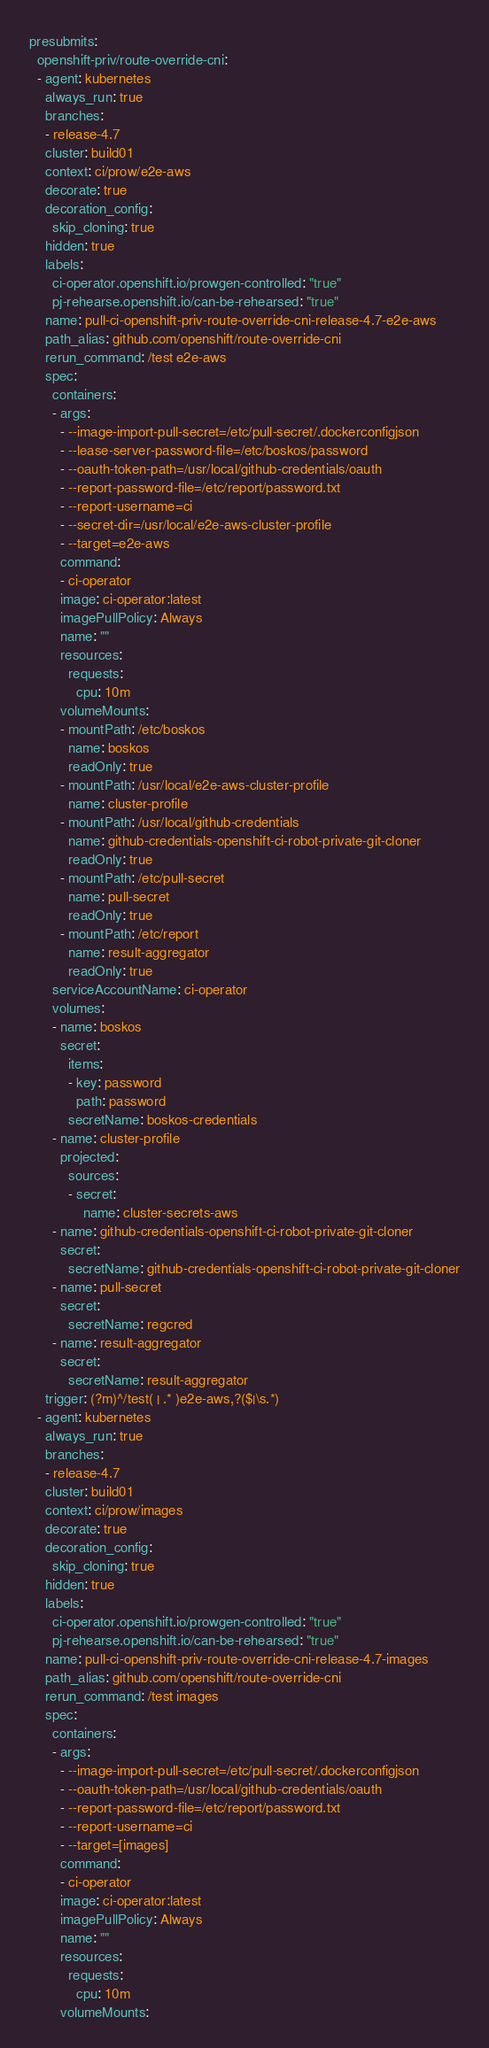Convert code to text. <code><loc_0><loc_0><loc_500><loc_500><_YAML_>presubmits:
  openshift-priv/route-override-cni:
  - agent: kubernetes
    always_run: true
    branches:
    - release-4.7
    cluster: build01
    context: ci/prow/e2e-aws
    decorate: true
    decoration_config:
      skip_cloning: true
    hidden: true
    labels:
      ci-operator.openshift.io/prowgen-controlled: "true"
      pj-rehearse.openshift.io/can-be-rehearsed: "true"
    name: pull-ci-openshift-priv-route-override-cni-release-4.7-e2e-aws
    path_alias: github.com/openshift/route-override-cni
    rerun_command: /test e2e-aws
    spec:
      containers:
      - args:
        - --image-import-pull-secret=/etc/pull-secret/.dockerconfigjson
        - --lease-server-password-file=/etc/boskos/password
        - --oauth-token-path=/usr/local/github-credentials/oauth
        - --report-password-file=/etc/report/password.txt
        - --report-username=ci
        - --secret-dir=/usr/local/e2e-aws-cluster-profile
        - --target=e2e-aws
        command:
        - ci-operator
        image: ci-operator:latest
        imagePullPolicy: Always
        name: ""
        resources:
          requests:
            cpu: 10m
        volumeMounts:
        - mountPath: /etc/boskos
          name: boskos
          readOnly: true
        - mountPath: /usr/local/e2e-aws-cluster-profile
          name: cluster-profile
        - mountPath: /usr/local/github-credentials
          name: github-credentials-openshift-ci-robot-private-git-cloner
          readOnly: true
        - mountPath: /etc/pull-secret
          name: pull-secret
          readOnly: true
        - mountPath: /etc/report
          name: result-aggregator
          readOnly: true
      serviceAccountName: ci-operator
      volumes:
      - name: boskos
        secret:
          items:
          - key: password
            path: password
          secretName: boskos-credentials
      - name: cluster-profile
        projected:
          sources:
          - secret:
              name: cluster-secrets-aws
      - name: github-credentials-openshift-ci-robot-private-git-cloner
        secret:
          secretName: github-credentials-openshift-ci-robot-private-git-cloner
      - name: pull-secret
        secret:
          secretName: regcred
      - name: result-aggregator
        secret:
          secretName: result-aggregator
    trigger: (?m)^/test( | .* )e2e-aws,?($|\s.*)
  - agent: kubernetes
    always_run: true
    branches:
    - release-4.7
    cluster: build01
    context: ci/prow/images
    decorate: true
    decoration_config:
      skip_cloning: true
    hidden: true
    labels:
      ci-operator.openshift.io/prowgen-controlled: "true"
      pj-rehearse.openshift.io/can-be-rehearsed: "true"
    name: pull-ci-openshift-priv-route-override-cni-release-4.7-images
    path_alias: github.com/openshift/route-override-cni
    rerun_command: /test images
    spec:
      containers:
      - args:
        - --image-import-pull-secret=/etc/pull-secret/.dockerconfigjson
        - --oauth-token-path=/usr/local/github-credentials/oauth
        - --report-password-file=/etc/report/password.txt
        - --report-username=ci
        - --target=[images]
        command:
        - ci-operator
        image: ci-operator:latest
        imagePullPolicy: Always
        name: ""
        resources:
          requests:
            cpu: 10m
        volumeMounts:</code> 